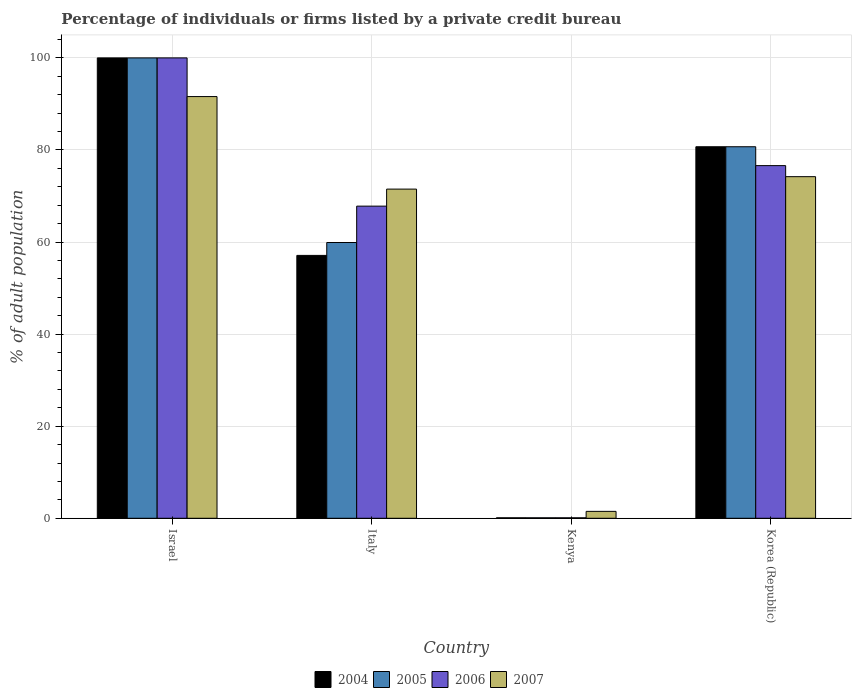How many different coloured bars are there?
Your answer should be very brief. 4. How many groups of bars are there?
Your answer should be compact. 4. How many bars are there on the 4th tick from the left?
Ensure brevity in your answer.  4. What is the percentage of population listed by a private credit bureau in 2004 in Israel?
Offer a very short reply. 100. In which country was the percentage of population listed by a private credit bureau in 2007 minimum?
Provide a succinct answer. Kenya. What is the total percentage of population listed by a private credit bureau in 2006 in the graph?
Your answer should be compact. 244.5. What is the difference between the percentage of population listed by a private credit bureau in 2007 in Italy and that in Korea (Republic)?
Provide a short and direct response. -2.7. What is the difference between the percentage of population listed by a private credit bureau in 2004 in Israel and the percentage of population listed by a private credit bureau in 2005 in Kenya?
Keep it short and to the point. 99.9. What is the average percentage of population listed by a private credit bureau in 2007 per country?
Your answer should be compact. 59.7. In how many countries, is the percentage of population listed by a private credit bureau in 2005 greater than 56 %?
Give a very brief answer. 3. What is the ratio of the percentage of population listed by a private credit bureau in 2007 in Israel to that in Kenya?
Keep it short and to the point. 61.07. Is the percentage of population listed by a private credit bureau in 2007 in Italy less than that in Kenya?
Provide a succinct answer. No. Is the difference between the percentage of population listed by a private credit bureau in 2004 in Kenya and Korea (Republic) greater than the difference between the percentage of population listed by a private credit bureau in 2007 in Kenya and Korea (Republic)?
Give a very brief answer. No. What is the difference between the highest and the second highest percentage of population listed by a private credit bureau in 2007?
Offer a terse response. -17.4. What is the difference between the highest and the lowest percentage of population listed by a private credit bureau in 2007?
Your response must be concise. 90.1. In how many countries, is the percentage of population listed by a private credit bureau in 2007 greater than the average percentage of population listed by a private credit bureau in 2007 taken over all countries?
Your answer should be compact. 3. Is it the case that in every country, the sum of the percentage of population listed by a private credit bureau in 2006 and percentage of population listed by a private credit bureau in 2004 is greater than the sum of percentage of population listed by a private credit bureau in 2007 and percentage of population listed by a private credit bureau in 2005?
Your answer should be very brief. No. What does the 1st bar from the left in Kenya represents?
Keep it short and to the point. 2004. What does the 3rd bar from the right in Kenya represents?
Keep it short and to the point. 2005. How many bars are there?
Give a very brief answer. 16. Where does the legend appear in the graph?
Offer a terse response. Bottom center. How many legend labels are there?
Your response must be concise. 4. How are the legend labels stacked?
Your answer should be compact. Horizontal. What is the title of the graph?
Your response must be concise. Percentage of individuals or firms listed by a private credit bureau. What is the label or title of the Y-axis?
Offer a terse response. % of adult population. What is the % of adult population in 2004 in Israel?
Provide a succinct answer. 100. What is the % of adult population in 2005 in Israel?
Offer a very short reply. 100. What is the % of adult population of 2007 in Israel?
Your response must be concise. 91.6. What is the % of adult population in 2004 in Italy?
Provide a succinct answer. 57.1. What is the % of adult population in 2005 in Italy?
Provide a short and direct response. 59.9. What is the % of adult population in 2006 in Italy?
Give a very brief answer. 67.8. What is the % of adult population in 2007 in Italy?
Provide a succinct answer. 71.5. What is the % of adult population of 2004 in Kenya?
Provide a short and direct response. 0.1. What is the % of adult population in 2005 in Kenya?
Your answer should be very brief. 0.1. What is the % of adult population of 2004 in Korea (Republic)?
Your response must be concise. 80.7. What is the % of adult population of 2005 in Korea (Republic)?
Your answer should be compact. 80.7. What is the % of adult population in 2006 in Korea (Republic)?
Provide a short and direct response. 76.6. What is the % of adult population of 2007 in Korea (Republic)?
Offer a terse response. 74.2. Across all countries, what is the maximum % of adult population of 2005?
Offer a very short reply. 100. Across all countries, what is the maximum % of adult population of 2006?
Provide a short and direct response. 100. Across all countries, what is the maximum % of adult population of 2007?
Keep it short and to the point. 91.6. Across all countries, what is the minimum % of adult population in 2007?
Provide a succinct answer. 1.5. What is the total % of adult population in 2004 in the graph?
Provide a short and direct response. 237.9. What is the total % of adult population of 2005 in the graph?
Your response must be concise. 240.7. What is the total % of adult population in 2006 in the graph?
Your answer should be very brief. 244.5. What is the total % of adult population of 2007 in the graph?
Your answer should be compact. 238.8. What is the difference between the % of adult population in 2004 in Israel and that in Italy?
Ensure brevity in your answer.  42.9. What is the difference between the % of adult population of 2005 in Israel and that in Italy?
Provide a succinct answer. 40.1. What is the difference between the % of adult population of 2006 in Israel and that in Italy?
Provide a succinct answer. 32.2. What is the difference between the % of adult population of 2007 in Israel and that in Italy?
Offer a terse response. 20.1. What is the difference between the % of adult population in 2004 in Israel and that in Kenya?
Ensure brevity in your answer.  99.9. What is the difference between the % of adult population in 2005 in Israel and that in Kenya?
Ensure brevity in your answer.  99.9. What is the difference between the % of adult population of 2006 in Israel and that in Kenya?
Your answer should be very brief. 99.9. What is the difference between the % of adult population of 2007 in Israel and that in Kenya?
Ensure brevity in your answer.  90.1. What is the difference between the % of adult population in 2004 in Israel and that in Korea (Republic)?
Offer a very short reply. 19.3. What is the difference between the % of adult population of 2005 in Israel and that in Korea (Republic)?
Ensure brevity in your answer.  19.3. What is the difference between the % of adult population in 2006 in Israel and that in Korea (Republic)?
Provide a succinct answer. 23.4. What is the difference between the % of adult population in 2007 in Israel and that in Korea (Republic)?
Ensure brevity in your answer.  17.4. What is the difference between the % of adult population of 2004 in Italy and that in Kenya?
Keep it short and to the point. 57. What is the difference between the % of adult population of 2005 in Italy and that in Kenya?
Offer a very short reply. 59.8. What is the difference between the % of adult population in 2006 in Italy and that in Kenya?
Ensure brevity in your answer.  67.7. What is the difference between the % of adult population of 2007 in Italy and that in Kenya?
Provide a short and direct response. 70. What is the difference between the % of adult population of 2004 in Italy and that in Korea (Republic)?
Give a very brief answer. -23.6. What is the difference between the % of adult population of 2005 in Italy and that in Korea (Republic)?
Your answer should be compact. -20.8. What is the difference between the % of adult population in 2007 in Italy and that in Korea (Republic)?
Your answer should be very brief. -2.7. What is the difference between the % of adult population in 2004 in Kenya and that in Korea (Republic)?
Provide a short and direct response. -80.6. What is the difference between the % of adult population of 2005 in Kenya and that in Korea (Republic)?
Offer a terse response. -80.6. What is the difference between the % of adult population of 2006 in Kenya and that in Korea (Republic)?
Your response must be concise. -76.5. What is the difference between the % of adult population of 2007 in Kenya and that in Korea (Republic)?
Offer a very short reply. -72.7. What is the difference between the % of adult population of 2004 in Israel and the % of adult population of 2005 in Italy?
Your response must be concise. 40.1. What is the difference between the % of adult population of 2004 in Israel and the % of adult population of 2006 in Italy?
Your response must be concise. 32.2. What is the difference between the % of adult population in 2004 in Israel and the % of adult population in 2007 in Italy?
Your answer should be compact. 28.5. What is the difference between the % of adult population of 2005 in Israel and the % of adult population of 2006 in Italy?
Keep it short and to the point. 32.2. What is the difference between the % of adult population of 2004 in Israel and the % of adult population of 2005 in Kenya?
Your answer should be compact. 99.9. What is the difference between the % of adult population of 2004 in Israel and the % of adult population of 2006 in Kenya?
Give a very brief answer. 99.9. What is the difference between the % of adult population of 2004 in Israel and the % of adult population of 2007 in Kenya?
Give a very brief answer. 98.5. What is the difference between the % of adult population of 2005 in Israel and the % of adult population of 2006 in Kenya?
Give a very brief answer. 99.9. What is the difference between the % of adult population in 2005 in Israel and the % of adult population in 2007 in Kenya?
Your answer should be compact. 98.5. What is the difference between the % of adult population of 2006 in Israel and the % of adult population of 2007 in Kenya?
Provide a succinct answer. 98.5. What is the difference between the % of adult population of 2004 in Israel and the % of adult population of 2005 in Korea (Republic)?
Make the answer very short. 19.3. What is the difference between the % of adult population in 2004 in Israel and the % of adult population in 2006 in Korea (Republic)?
Keep it short and to the point. 23.4. What is the difference between the % of adult population in 2004 in Israel and the % of adult population in 2007 in Korea (Republic)?
Ensure brevity in your answer.  25.8. What is the difference between the % of adult population of 2005 in Israel and the % of adult population of 2006 in Korea (Republic)?
Provide a succinct answer. 23.4. What is the difference between the % of adult population in 2005 in Israel and the % of adult population in 2007 in Korea (Republic)?
Provide a succinct answer. 25.8. What is the difference between the % of adult population in 2006 in Israel and the % of adult population in 2007 in Korea (Republic)?
Ensure brevity in your answer.  25.8. What is the difference between the % of adult population of 2004 in Italy and the % of adult population of 2005 in Kenya?
Offer a terse response. 57. What is the difference between the % of adult population in 2004 in Italy and the % of adult population in 2006 in Kenya?
Offer a terse response. 57. What is the difference between the % of adult population in 2004 in Italy and the % of adult population in 2007 in Kenya?
Your response must be concise. 55.6. What is the difference between the % of adult population of 2005 in Italy and the % of adult population of 2006 in Kenya?
Your answer should be compact. 59.8. What is the difference between the % of adult population of 2005 in Italy and the % of adult population of 2007 in Kenya?
Give a very brief answer. 58.4. What is the difference between the % of adult population in 2006 in Italy and the % of adult population in 2007 in Kenya?
Keep it short and to the point. 66.3. What is the difference between the % of adult population of 2004 in Italy and the % of adult population of 2005 in Korea (Republic)?
Provide a short and direct response. -23.6. What is the difference between the % of adult population of 2004 in Italy and the % of adult population of 2006 in Korea (Republic)?
Give a very brief answer. -19.5. What is the difference between the % of adult population in 2004 in Italy and the % of adult population in 2007 in Korea (Republic)?
Offer a very short reply. -17.1. What is the difference between the % of adult population of 2005 in Italy and the % of adult population of 2006 in Korea (Republic)?
Make the answer very short. -16.7. What is the difference between the % of adult population in 2005 in Italy and the % of adult population in 2007 in Korea (Republic)?
Offer a terse response. -14.3. What is the difference between the % of adult population in 2004 in Kenya and the % of adult population in 2005 in Korea (Republic)?
Offer a very short reply. -80.6. What is the difference between the % of adult population of 2004 in Kenya and the % of adult population of 2006 in Korea (Republic)?
Make the answer very short. -76.5. What is the difference between the % of adult population in 2004 in Kenya and the % of adult population in 2007 in Korea (Republic)?
Your response must be concise. -74.1. What is the difference between the % of adult population in 2005 in Kenya and the % of adult population in 2006 in Korea (Republic)?
Make the answer very short. -76.5. What is the difference between the % of adult population in 2005 in Kenya and the % of adult population in 2007 in Korea (Republic)?
Ensure brevity in your answer.  -74.1. What is the difference between the % of adult population in 2006 in Kenya and the % of adult population in 2007 in Korea (Republic)?
Provide a succinct answer. -74.1. What is the average % of adult population of 2004 per country?
Offer a terse response. 59.48. What is the average % of adult population in 2005 per country?
Provide a short and direct response. 60.17. What is the average % of adult population in 2006 per country?
Make the answer very short. 61.12. What is the average % of adult population in 2007 per country?
Your answer should be very brief. 59.7. What is the difference between the % of adult population in 2004 and % of adult population in 2005 in Israel?
Your answer should be very brief. 0. What is the difference between the % of adult population of 2004 and % of adult population of 2006 in Israel?
Give a very brief answer. 0. What is the difference between the % of adult population in 2005 and % of adult population in 2006 in Israel?
Your answer should be very brief. 0. What is the difference between the % of adult population in 2005 and % of adult population in 2007 in Israel?
Provide a succinct answer. 8.4. What is the difference between the % of adult population in 2004 and % of adult population in 2007 in Italy?
Your answer should be compact. -14.4. What is the difference between the % of adult population in 2004 and % of adult population in 2005 in Kenya?
Provide a short and direct response. 0. What is the difference between the % of adult population of 2004 and % of adult population of 2007 in Kenya?
Offer a very short reply. -1.4. What is the difference between the % of adult population in 2005 and % of adult population in 2007 in Kenya?
Your answer should be very brief. -1.4. What is the difference between the % of adult population of 2006 and % of adult population of 2007 in Kenya?
Offer a terse response. -1.4. What is the difference between the % of adult population of 2004 and % of adult population of 2005 in Korea (Republic)?
Ensure brevity in your answer.  0. What is the difference between the % of adult population of 2005 and % of adult population of 2007 in Korea (Republic)?
Provide a short and direct response. 6.5. What is the ratio of the % of adult population of 2004 in Israel to that in Italy?
Provide a short and direct response. 1.75. What is the ratio of the % of adult population of 2005 in Israel to that in Italy?
Your answer should be very brief. 1.67. What is the ratio of the % of adult population in 2006 in Israel to that in Italy?
Offer a terse response. 1.47. What is the ratio of the % of adult population in 2007 in Israel to that in Italy?
Provide a short and direct response. 1.28. What is the ratio of the % of adult population of 2004 in Israel to that in Kenya?
Your answer should be compact. 1000. What is the ratio of the % of adult population in 2005 in Israel to that in Kenya?
Provide a succinct answer. 1000. What is the ratio of the % of adult population of 2006 in Israel to that in Kenya?
Provide a succinct answer. 1000. What is the ratio of the % of adult population of 2007 in Israel to that in Kenya?
Your answer should be very brief. 61.07. What is the ratio of the % of adult population of 2004 in Israel to that in Korea (Republic)?
Your answer should be compact. 1.24. What is the ratio of the % of adult population in 2005 in Israel to that in Korea (Republic)?
Make the answer very short. 1.24. What is the ratio of the % of adult population in 2006 in Israel to that in Korea (Republic)?
Offer a terse response. 1.31. What is the ratio of the % of adult population in 2007 in Israel to that in Korea (Republic)?
Your answer should be compact. 1.23. What is the ratio of the % of adult population in 2004 in Italy to that in Kenya?
Give a very brief answer. 571. What is the ratio of the % of adult population of 2005 in Italy to that in Kenya?
Ensure brevity in your answer.  599. What is the ratio of the % of adult population in 2006 in Italy to that in Kenya?
Make the answer very short. 678. What is the ratio of the % of adult population of 2007 in Italy to that in Kenya?
Ensure brevity in your answer.  47.67. What is the ratio of the % of adult population in 2004 in Italy to that in Korea (Republic)?
Offer a very short reply. 0.71. What is the ratio of the % of adult population of 2005 in Italy to that in Korea (Republic)?
Keep it short and to the point. 0.74. What is the ratio of the % of adult population of 2006 in Italy to that in Korea (Republic)?
Keep it short and to the point. 0.89. What is the ratio of the % of adult population in 2007 in Italy to that in Korea (Republic)?
Your answer should be compact. 0.96. What is the ratio of the % of adult population of 2004 in Kenya to that in Korea (Republic)?
Offer a very short reply. 0. What is the ratio of the % of adult population of 2005 in Kenya to that in Korea (Republic)?
Give a very brief answer. 0. What is the ratio of the % of adult population of 2006 in Kenya to that in Korea (Republic)?
Ensure brevity in your answer.  0. What is the ratio of the % of adult population of 2007 in Kenya to that in Korea (Republic)?
Provide a short and direct response. 0.02. What is the difference between the highest and the second highest % of adult population in 2004?
Your response must be concise. 19.3. What is the difference between the highest and the second highest % of adult population in 2005?
Keep it short and to the point. 19.3. What is the difference between the highest and the second highest % of adult population of 2006?
Offer a very short reply. 23.4. What is the difference between the highest and the second highest % of adult population in 2007?
Provide a short and direct response. 17.4. What is the difference between the highest and the lowest % of adult population of 2004?
Keep it short and to the point. 99.9. What is the difference between the highest and the lowest % of adult population of 2005?
Give a very brief answer. 99.9. What is the difference between the highest and the lowest % of adult population of 2006?
Your answer should be very brief. 99.9. What is the difference between the highest and the lowest % of adult population in 2007?
Give a very brief answer. 90.1. 